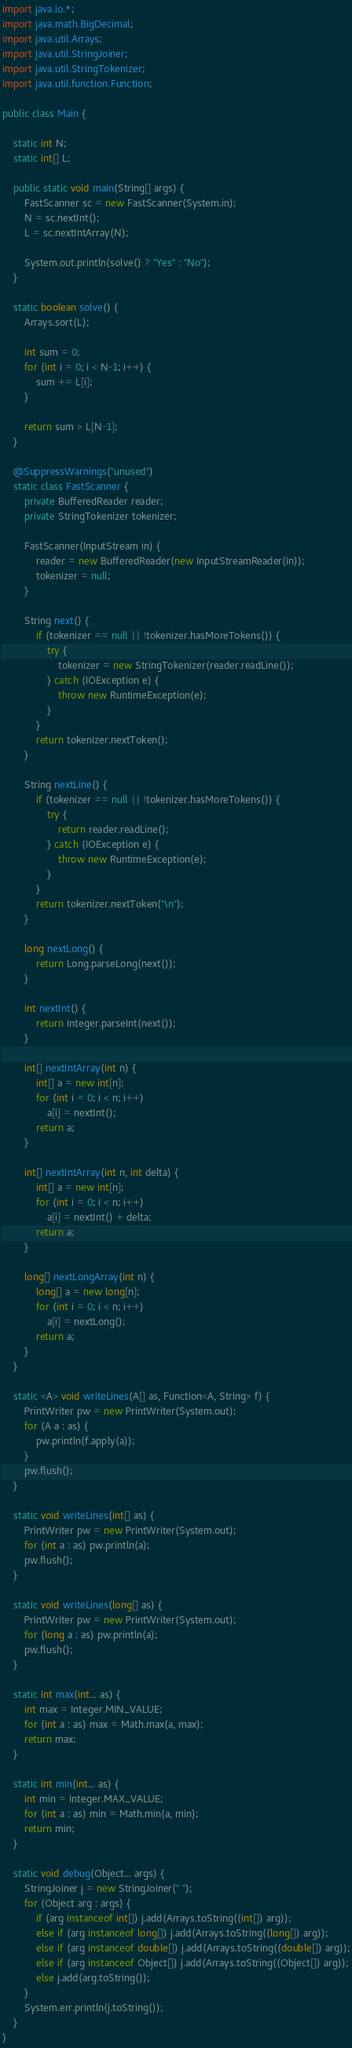<code> <loc_0><loc_0><loc_500><loc_500><_Java_>import java.io.*;
import java.math.BigDecimal;
import java.util.Arrays;
import java.util.StringJoiner;
import java.util.StringTokenizer;
import java.util.function.Function;

public class Main {

    static int N;
    static int[] L;

    public static void main(String[] args) {
        FastScanner sc = new FastScanner(System.in);
        N = sc.nextInt();
        L = sc.nextIntArray(N);

        System.out.println(solve() ? "Yes" : "No");
    }

    static boolean solve() {
        Arrays.sort(L);

        int sum = 0;
        for (int i = 0; i < N-1; i++) {
            sum += L[i];
        }

        return sum > L[N-1];
    }

    @SuppressWarnings("unused")
    static class FastScanner {
        private BufferedReader reader;
        private StringTokenizer tokenizer;

        FastScanner(InputStream in) {
            reader = new BufferedReader(new InputStreamReader(in));
            tokenizer = null;
        }

        String next() {
            if (tokenizer == null || !tokenizer.hasMoreTokens()) {
                try {
                    tokenizer = new StringTokenizer(reader.readLine());
                } catch (IOException e) {
                    throw new RuntimeException(e);
                }
            }
            return tokenizer.nextToken();
        }

        String nextLine() {
            if (tokenizer == null || !tokenizer.hasMoreTokens()) {
                try {
                    return reader.readLine();
                } catch (IOException e) {
                    throw new RuntimeException(e);
                }
            }
            return tokenizer.nextToken("\n");
        }

        long nextLong() {
            return Long.parseLong(next());
        }

        int nextInt() {
            return Integer.parseInt(next());
        }

        int[] nextIntArray(int n) {
            int[] a = new int[n];
            for (int i = 0; i < n; i++)
                a[i] = nextInt();
            return a;
        }

        int[] nextIntArray(int n, int delta) {
            int[] a = new int[n];
            for (int i = 0; i < n; i++)
                a[i] = nextInt() + delta;
            return a;
        }

        long[] nextLongArray(int n) {
            long[] a = new long[n];
            for (int i = 0; i < n; i++)
                a[i] = nextLong();
            return a;
        }
    }

    static <A> void writeLines(A[] as, Function<A, String> f) {
        PrintWriter pw = new PrintWriter(System.out);
        for (A a : as) {
            pw.println(f.apply(a));
        }
        pw.flush();
    }

    static void writeLines(int[] as) {
        PrintWriter pw = new PrintWriter(System.out);
        for (int a : as) pw.println(a);
        pw.flush();
    }

    static void writeLines(long[] as) {
        PrintWriter pw = new PrintWriter(System.out);
        for (long a : as) pw.println(a);
        pw.flush();
    }

    static int max(int... as) {
        int max = Integer.MIN_VALUE;
        for (int a : as) max = Math.max(a, max);
        return max;
    }

    static int min(int... as) {
        int min = Integer.MAX_VALUE;
        for (int a : as) min = Math.min(a, min);
        return min;
    }

    static void debug(Object... args) {
        StringJoiner j = new StringJoiner(" ");
        for (Object arg : args) {
            if (arg instanceof int[]) j.add(Arrays.toString((int[]) arg));
            else if (arg instanceof long[]) j.add(Arrays.toString((long[]) arg));
            else if (arg instanceof double[]) j.add(Arrays.toString((double[]) arg));
            else if (arg instanceof Object[]) j.add(Arrays.toString((Object[]) arg));
            else j.add(arg.toString());
        }
        System.err.println(j.toString());
    }
}
</code> 